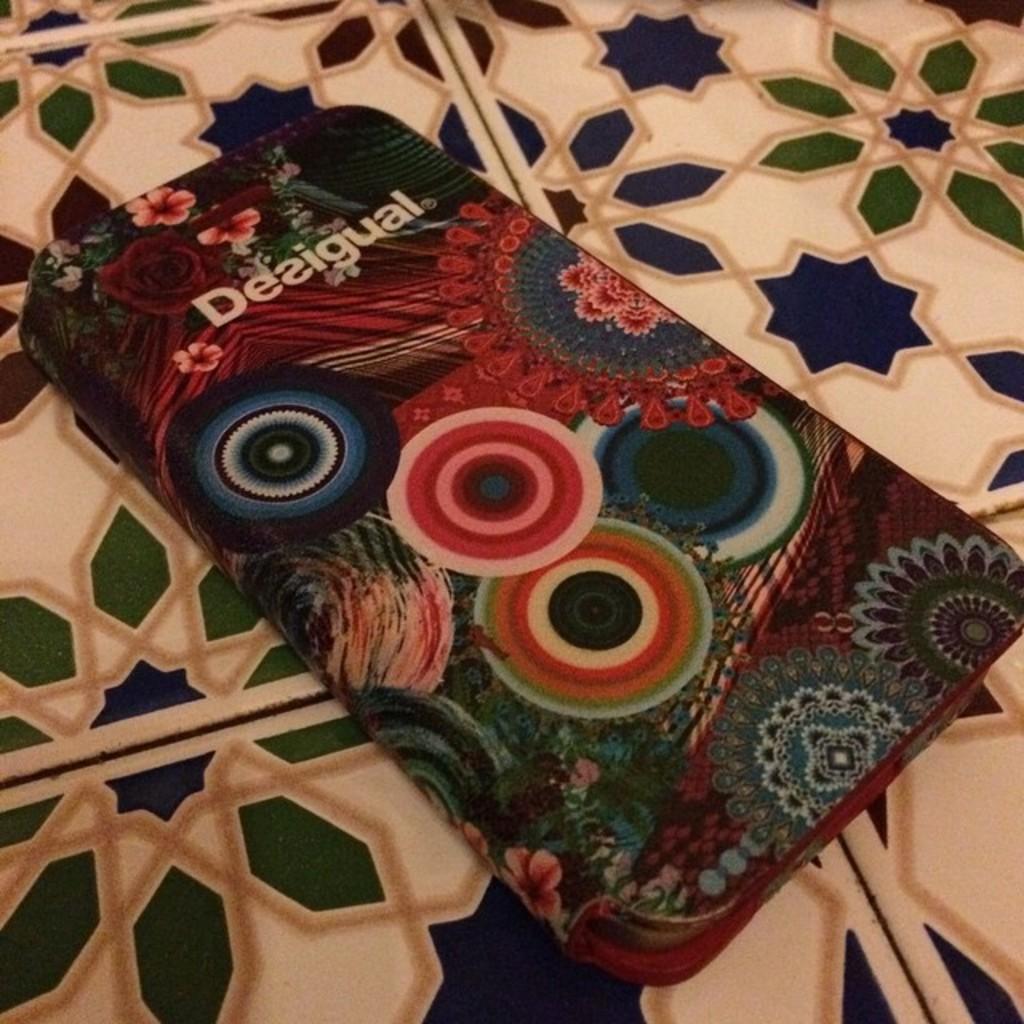Could you give a brief overview of what you see in this image? In this image I can see a box and on it I can see few designs and I can also see something is written on it. 